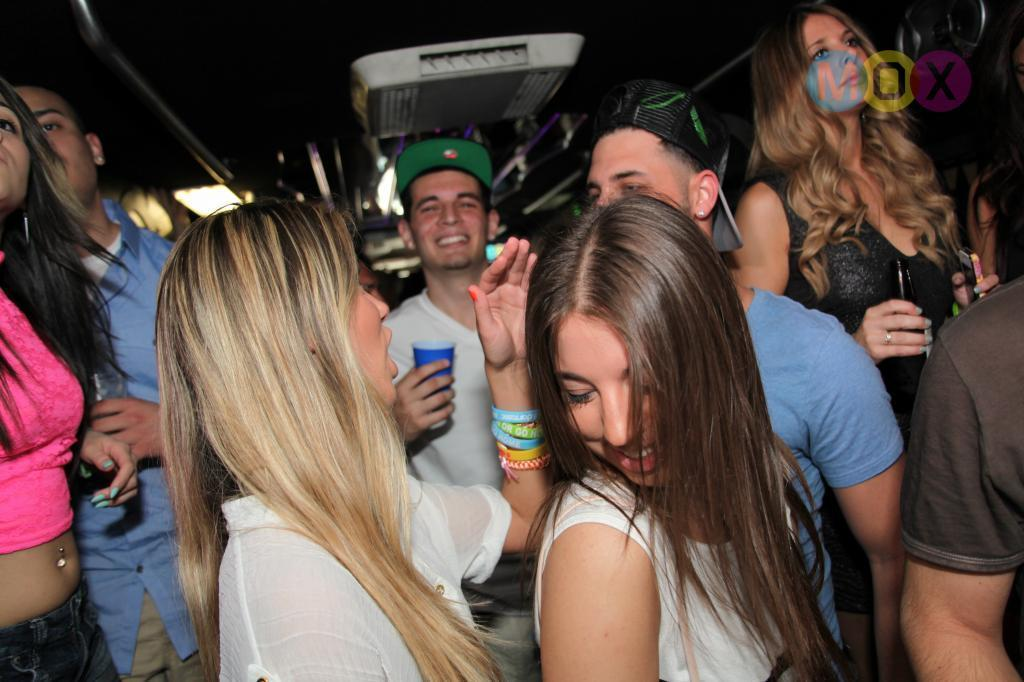What is happening in the foreground of the image? There are people in the foreground of the image. What is the man holding in the image? The man is holding a blue glass. Can you describe the object at the top of the image? There is a white object at the top of the image. How would you describe the background of the image? The background image is unclear. How many leaves are on the sheet in the image? There are no leaves or sheets present in the image. What type of coil is being used by the people in the foreground? There is no coil visible in the image; the people are not using any coils. 